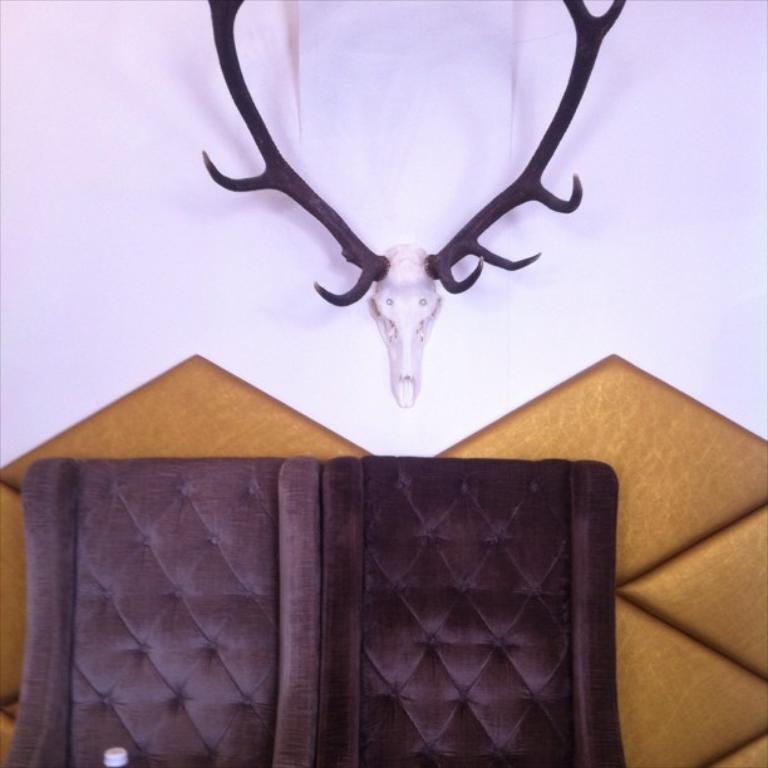Describe this image in one or two sentences. In this picture we can see 2 brown chairs. In the background, we can see a deer head mounted on a wall. 